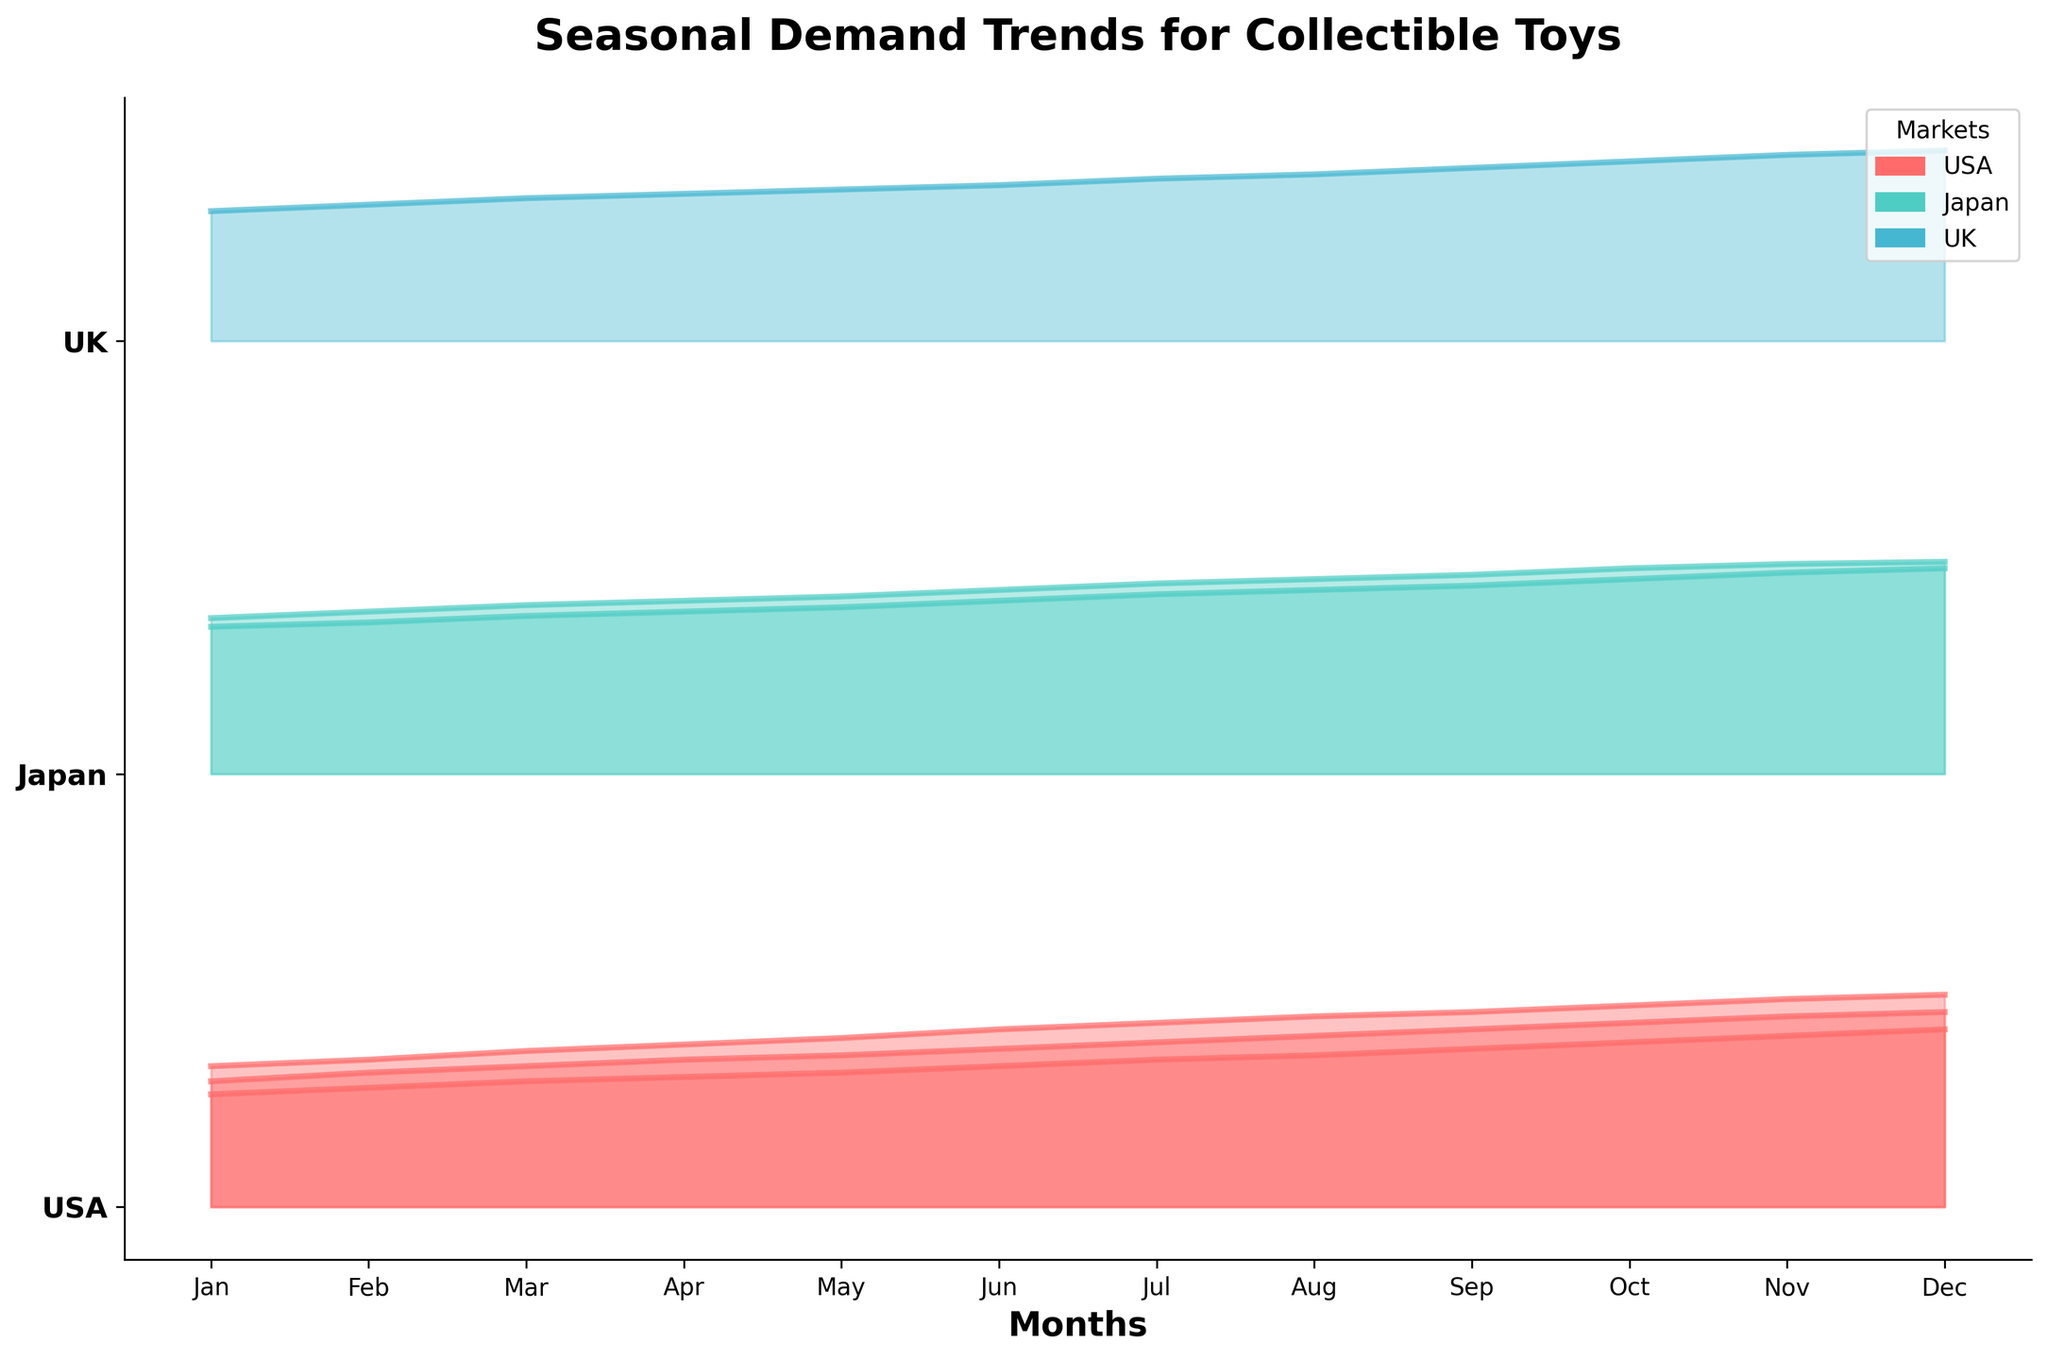What is the title of the plot? The plot's title is usually located at the top and is the most prominent text, summarizing the overall topic. Here, it reads "Seasonal Demand Trends for Collectible Toys".
Answer: Seasonal Demand Trends for Collectible Toys Which market exhibits the highest demand for toys in December? Inspect the peak of the demand scores in December across all markets. The plot line representing December for Japan seems to reach the highest value.
Answer: Japan In which month did the USA see a notable increase in demand for Funko Pop toys? Observe the Funko Pop demand trend line for USA. Look for a month where there is a sharp increase compared to the previous month. There's a noticeable increase from July to August.
Answer: August Compare the demand trends of Gundam in Japan and Funko Pop in the USA. Which one has higher peaks during the year? Analyze the Gundam trend line for Japan and Funko Pop trend line for the USA. Gundam in Japan consistently peaks higher throughout the months.
Answer: Gundam in Japan What is the general trend for Warhammer demand in the UK from January to December? Look at the Warhammer line for the UK from start to end. It shows a generally increasing trend over the months.
Answer: Increasing How does the demand for LEGO Minifigures in the USA change from July to September? Track the LEGO Minifigures demand line from July through September. There is a clear upward trend where the demand increases from 76 in July to 82 in September.
Answer: Increasing Which toy line in Japan shows the highest demand score in the month of October? Find the October month data for Japan and locate the highest peak. Gundam exhibits the highest demand score.
Answer: Gundam What can you infer about the seasonality of Hot Wheels demand in the USA? Observe the Hot Wheels trend line for USA across all months. It shows a gradual increase, particularly towards the end of the year (October to December).
Answer: Increases towards the end of the year Is there a toy line that consistently shows the lowest demand in the USA throughout the year? Compare all toy lines in the USA. Hot Wheels consistently shows the lowest demand when compared with Funko Pop and LEGO Minifigures.
Answer: Hot Wheels Identify the month and market combination that shows the lowest demand score. Look for the lowest peak across all months and markets. The lowest peak is for Hot Wheels in the USA during January.
Answer: USA, January 